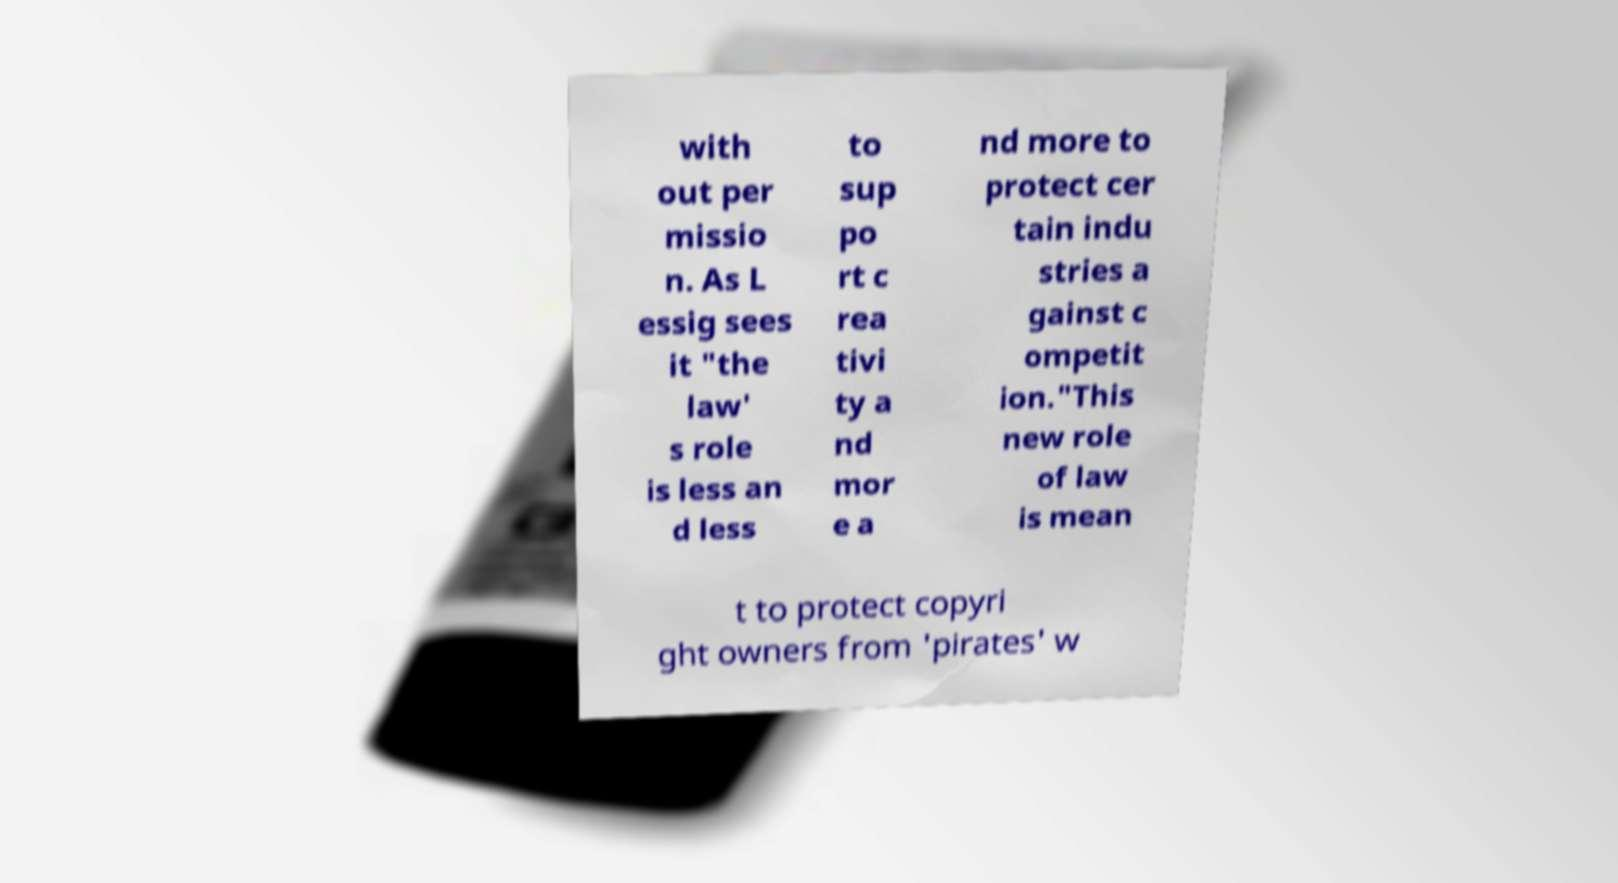Please identify and transcribe the text found in this image. with out per missio n. As L essig sees it "the law' s role is less an d less to sup po rt c rea tivi ty a nd mor e a nd more to protect cer tain indu stries a gainst c ompetit ion."This new role of law is mean t to protect copyri ght owners from 'pirates' w 